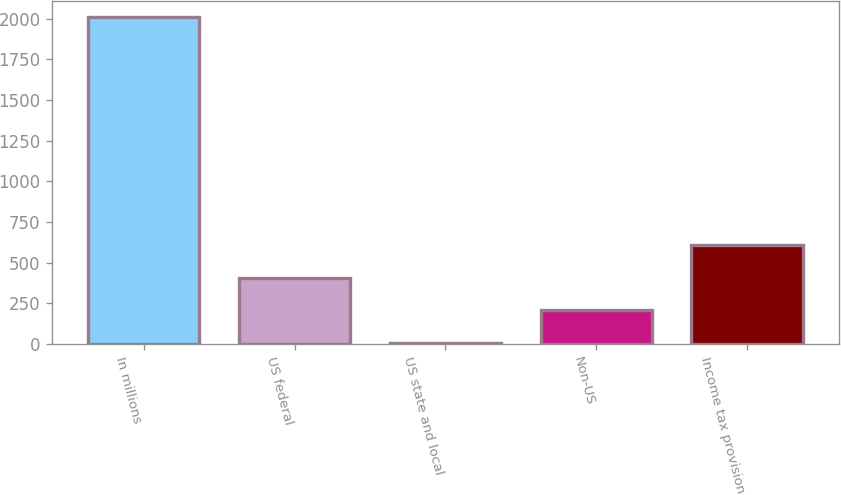Convert chart to OTSL. <chart><loc_0><loc_0><loc_500><loc_500><bar_chart><fcel>In millions<fcel>US federal<fcel>US state and local<fcel>Non-US<fcel>Income tax provision<nl><fcel>2009<fcel>407.4<fcel>7<fcel>207.2<fcel>607.6<nl></chart> 